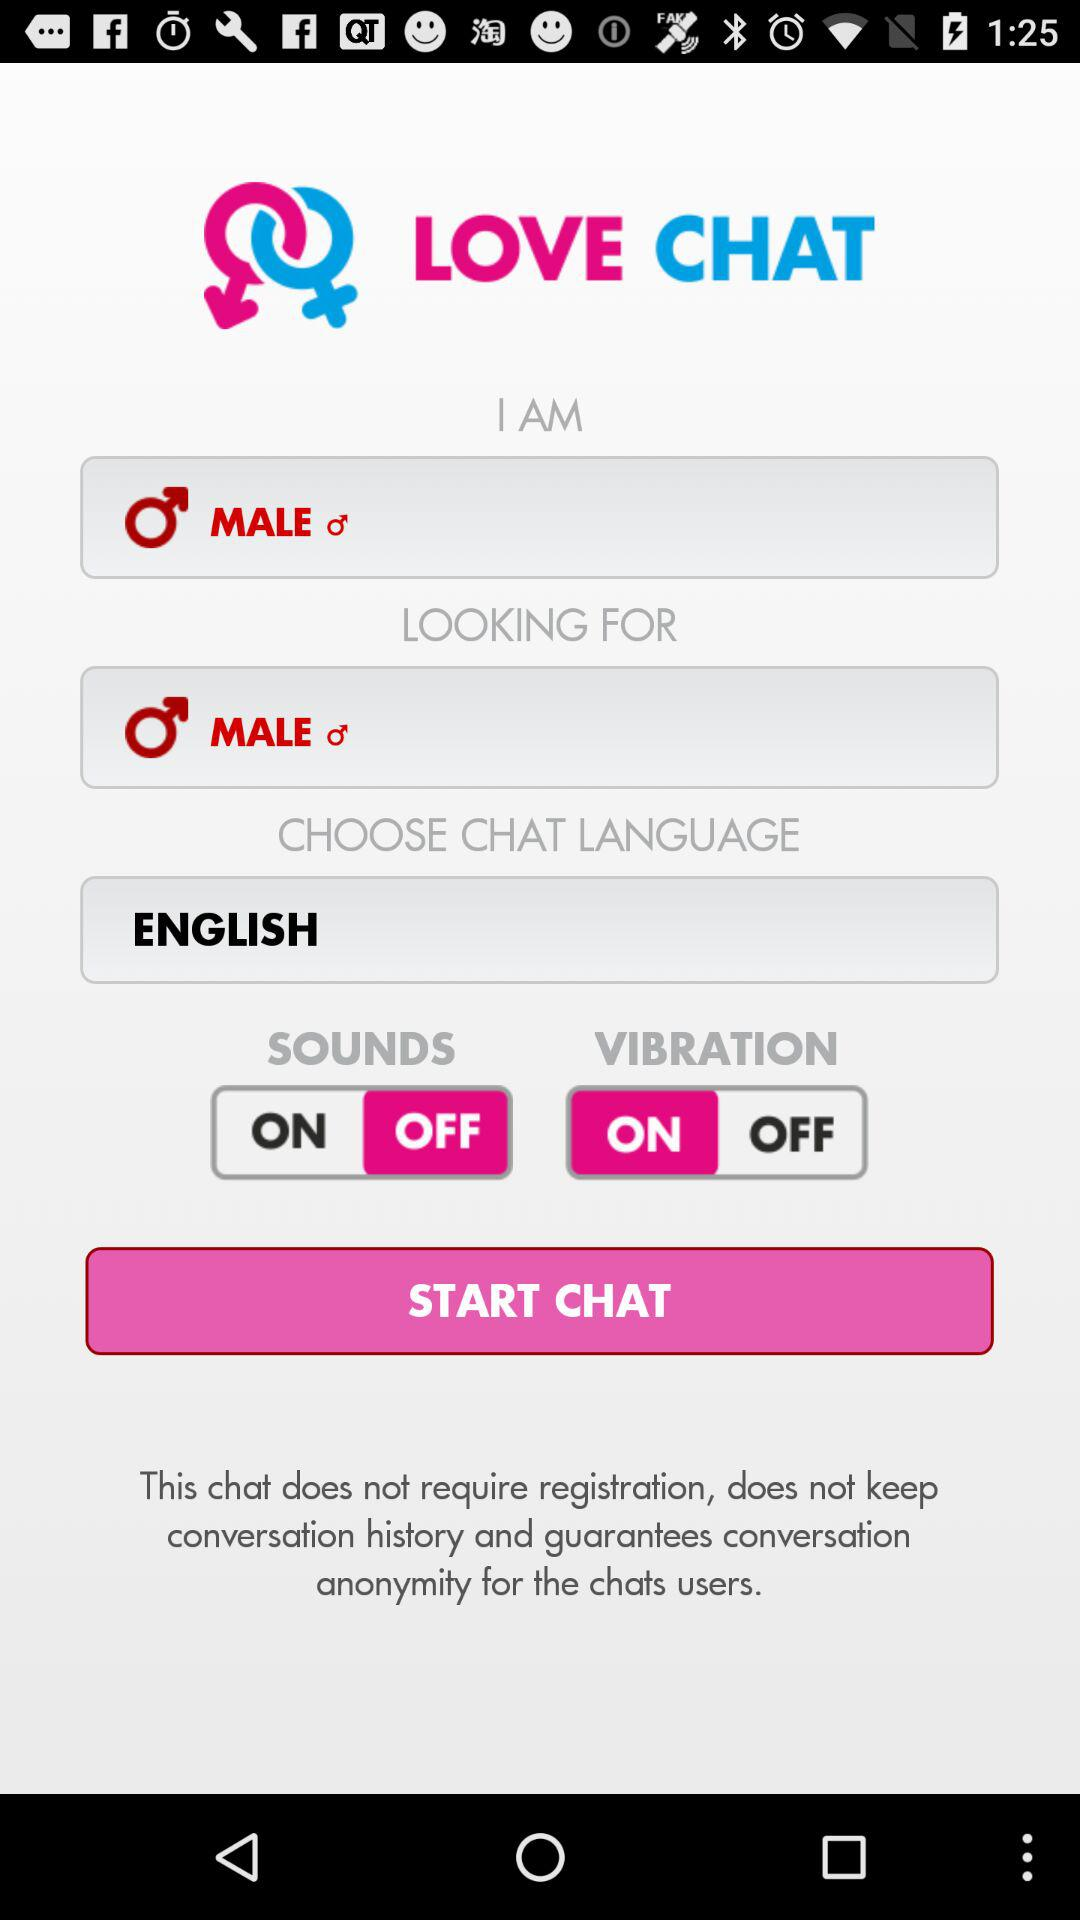Which language is chosen? The chosen language is English. 